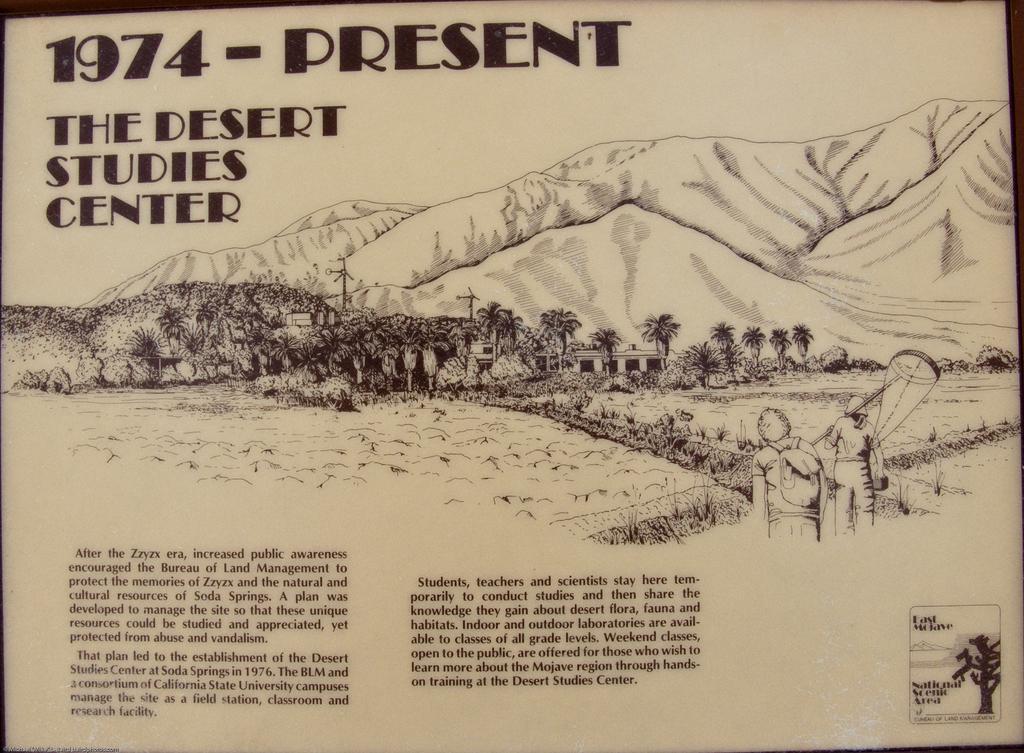How would you summarize this image in a sentence or two? In this image there is a board. There are pictures and text on the image. In the center there are pictures of mountains, trees and houses. In front of the house there are two persons standing. 